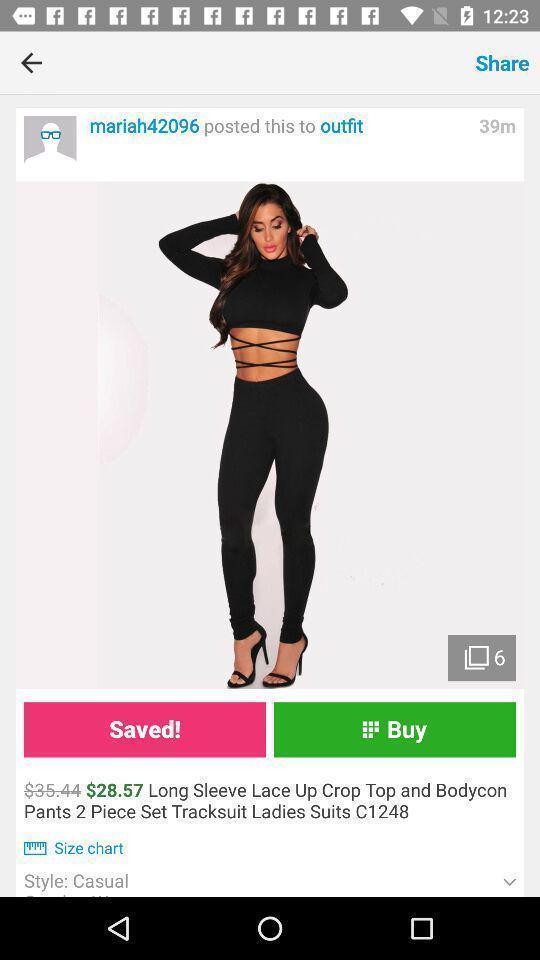Summarize the main components in this picture. Women clothing details page displayed of a online shopping app. 